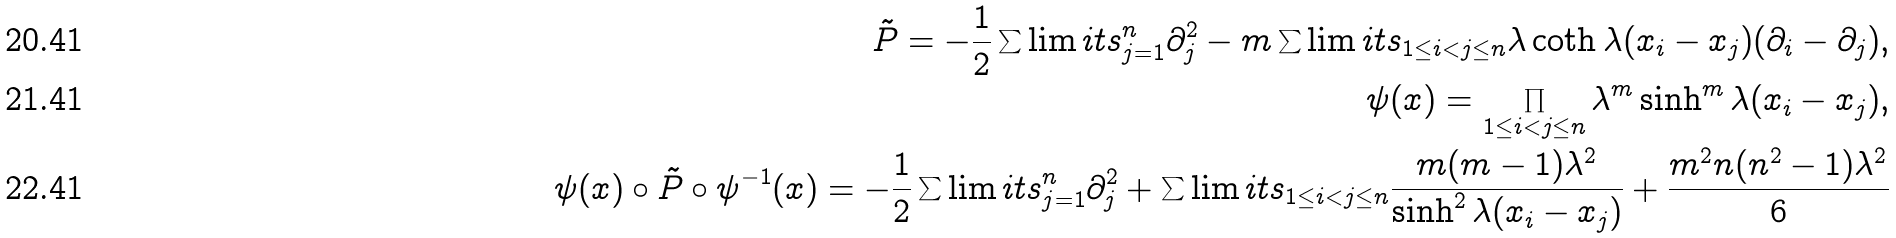<formula> <loc_0><loc_0><loc_500><loc_500>\tilde { P } = - \frac { 1 } { 2 } \sum \lim i t s _ { j = 1 } ^ { n } \partial _ { j } ^ { 2 } - m \sum \lim i t s _ { 1 \leq i < j \leq n } \lambda \coth \lambda ( x _ { i } - x _ { j } ) ( \partial _ { i } - \partial _ { j } ) , \\ \psi ( x ) = \prod _ { 1 \leq i < j \leq n } \lambda ^ { m } \sinh ^ { m } \lambda ( x _ { i } - x _ { j } ) , \\ \psi ( x ) \circ \tilde { P } \circ \psi ^ { - 1 } ( x ) = - \frac { 1 } { 2 } \sum \lim i t s _ { j = 1 } ^ { n } \partial _ { j } ^ { 2 } + \sum \lim i t s _ { 1 \leq i < j \leq n } \frac { m ( m - 1 ) \lambda ^ { 2 } } { \sinh ^ { 2 } \lambda ( x _ { i } - x _ { j } ) } + \frac { m ^ { 2 } n ( n ^ { 2 } - 1 ) \lambda ^ { 2 } } { 6 }</formula> 